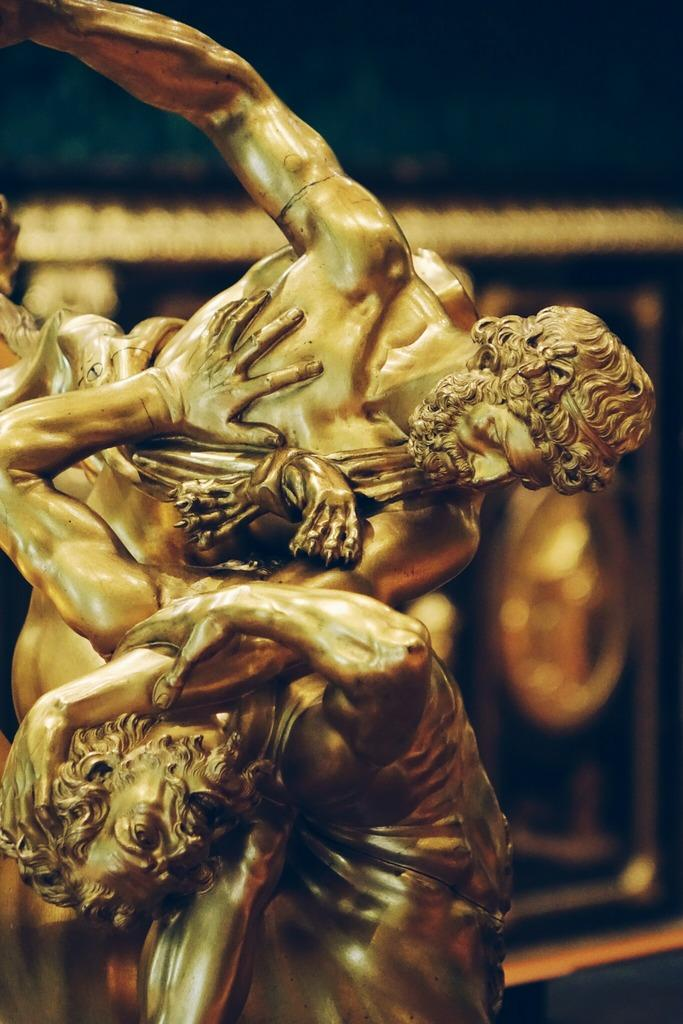What is the main subject in the image? There is a statue in the image. Can you describe the statue? Unfortunately, the provided facts do not give any details about the statue's appearance or characteristics. What can be seen in the background of the image? There is a golden color object in the background of the image. Is there a bat involved in a fight with the statue in the image? No, there is no bat or any indication of a fight in the image. The image only features a statue and a golden color object in the background. 